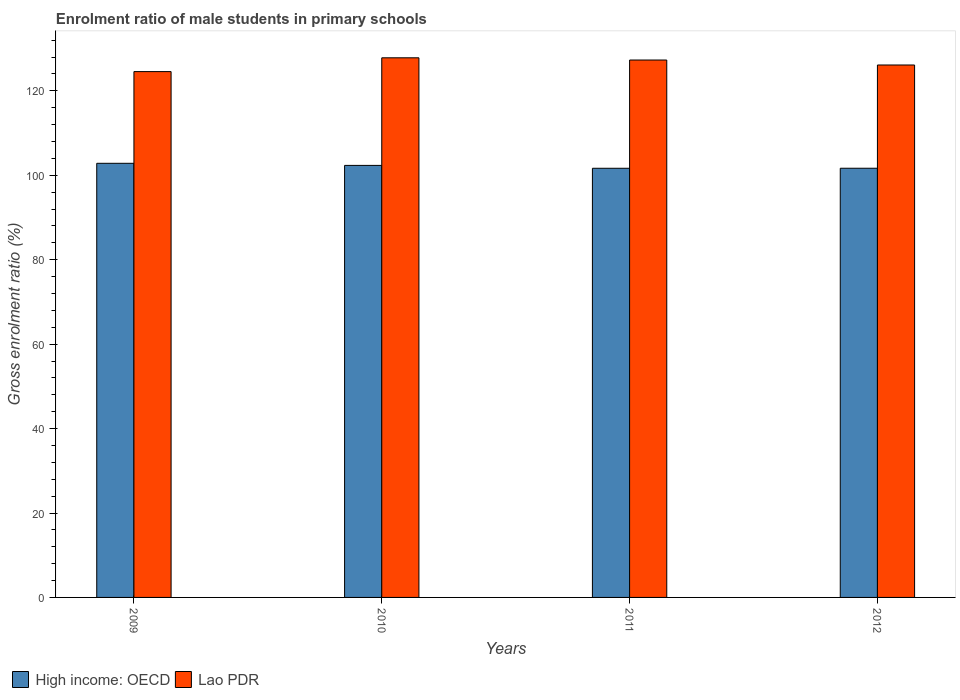Are the number of bars on each tick of the X-axis equal?
Keep it short and to the point. Yes. How many bars are there on the 3rd tick from the right?
Provide a succinct answer. 2. What is the label of the 3rd group of bars from the left?
Your response must be concise. 2011. What is the enrolment ratio of male students in primary schools in High income: OECD in 2010?
Ensure brevity in your answer.  102.35. Across all years, what is the maximum enrolment ratio of male students in primary schools in Lao PDR?
Offer a very short reply. 127.83. Across all years, what is the minimum enrolment ratio of male students in primary schools in Lao PDR?
Your response must be concise. 124.56. In which year was the enrolment ratio of male students in primary schools in High income: OECD maximum?
Provide a succinct answer. 2009. In which year was the enrolment ratio of male students in primary schools in High income: OECD minimum?
Offer a very short reply. 2011. What is the total enrolment ratio of male students in primary schools in High income: OECD in the graph?
Keep it short and to the point. 408.52. What is the difference between the enrolment ratio of male students in primary schools in Lao PDR in 2010 and that in 2012?
Your answer should be very brief. 1.7. What is the difference between the enrolment ratio of male students in primary schools in High income: OECD in 2011 and the enrolment ratio of male students in primary schools in Lao PDR in 2009?
Give a very brief answer. -22.9. What is the average enrolment ratio of male students in primary schools in High income: OECD per year?
Your answer should be compact. 102.13. In the year 2010, what is the difference between the enrolment ratio of male students in primary schools in Lao PDR and enrolment ratio of male students in primary schools in High income: OECD?
Provide a short and direct response. 25.49. In how many years, is the enrolment ratio of male students in primary schools in High income: OECD greater than 20 %?
Provide a short and direct response. 4. What is the ratio of the enrolment ratio of male students in primary schools in Lao PDR in 2010 to that in 2012?
Offer a very short reply. 1.01. Is the enrolment ratio of male students in primary schools in Lao PDR in 2009 less than that in 2010?
Provide a short and direct response. Yes. Is the difference between the enrolment ratio of male students in primary schools in Lao PDR in 2009 and 2012 greater than the difference between the enrolment ratio of male students in primary schools in High income: OECD in 2009 and 2012?
Provide a short and direct response. No. What is the difference between the highest and the second highest enrolment ratio of male students in primary schools in Lao PDR?
Make the answer very short. 0.53. What is the difference between the highest and the lowest enrolment ratio of male students in primary schools in Lao PDR?
Give a very brief answer. 3.27. In how many years, is the enrolment ratio of male students in primary schools in Lao PDR greater than the average enrolment ratio of male students in primary schools in Lao PDR taken over all years?
Your answer should be very brief. 2. What does the 2nd bar from the left in 2009 represents?
Your answer should be compact. Lao PDR. What does the 2nd bar from the right in 2010 represents?
Your response must be concise. High income: OECD. How many bars are there?
Give a very brief answer. 8. Are the values on the major ticks of Y-axis written in scientific E-notation?
Offer a very short reply. No. Does the graph contain any zero values?
Your response must be concise. No. Does the graph contain grids?
Your response must be concise. No. Where does the legend appear in the graph?
Your answer should be very brief. Bottom left. How many legend labels are there?
Provide a succinct answer. 2. How are the legend labels stacked?
Your answer should be very brief. Horizontal. What is the title of the graph?
Offer a very short reply. Enrolment ratio of male students in primary schools. What is the Gross enrolment ratio (%) of High income: OECD in 2009?
Make the answer very short. 102.84. What is the Gross enrolment ratio (%) of Lao PDR in 2009?
Provide a short and direct response. 124.56. What is the Gross enrolment ratio (%) in High income: OECD in 2010?
Your answer should be compact. 102.35. What is the Gross enrolment ratio (%) of Lao PDR in 2010?
Provide a short and direct response. 127.83. What is the Gross enrolment ratio (%) in High income: OECD in 2011?
Keep it short and to the point. 101.67. What is the Gross enrolment ratio (%) in Lao PDR in 2011?
Give a very brief answer. 127.31. What is the Gross enrolment ratio (%) in High income: OECD in 2012?
Your response must be concise. 101.67. What is the Gross enrolment ratio (%) in Lao PDR in 2012?
Provide a succinct answer. 126.13. Across all years, what is the maximum Gross enrolment ratio (%) of High income: OECD?
Offer a terse response. 102.84. Across all years, what is the maximum Gross enrolment ratio (%) of Lao PDR?
Offer a terse response. 127.83. Across all years, what is the minimum Gross enrolment ratio (%) in High income: OECD?
Your answer should be compact. 101.67. Across all years, what is the minimum Gross enrolment ratio (%) in Lao PDR?
Your response must be concise. 124.56. What is the total Gross enrolment ratio (%) in High income: OECD in the graph?
Offer a terse response. 408.52. What is the total Gross enrolment ratio (%) in Lao PDR in the graph?
Give a very brief answer. 505.84. What is the difference between the Gross enrolment ratio (%) in High income: OECD in 2009 and that in 2010?
Your response must be concise. 0.5. What is the difference between the Gross enrolment ratio (%) of Lao PDR in 2009 and that in 2010?
Provide a short and direct response. -3.27. What is the difference between the Gross enrolment ratio (%) in High income: OECD in 2009 and that in 2011?
Your response must be concise. 1.17. What is the difference between the Gross enrolment ratio (%) of Lao PDR in 2009 and that in 2011?
Ensure brevity in your answer.  -2.74. What is the difference between the Gross enrolment ratio (%) of High income: OECD in 2009 and that in 2012?
Offer a very short reply. 1.17. What is the difference between the Gross enrolment ratio (%) of Lao PDR in 2009 and that in 2012?
Your response must be concise. -1.57. What is the difference between the Gross enrolment ratio (%) in High income: OECD in 2010 and that in 2011?
Provide a succinct answer. 0.68. What is the difference between the Gross enrolment ratio (%) of Lao PDR in 2010 and that in 2011?
Give a very brief answer. 0.53. What is the difference between the Gross enrolment ratio (%) in High income: OECD in 2010 and that in 2012?
Provide a succinct answer. 0.67. What is the difference between the Gross enrolment ratio (%) in Lao PDR in 2010 and that in 2012?
Keep it short and to the point. 1.7. What is the difference between the Gross enrolment ratio (%) of High income: OECD in 2011 and that in 2012?
Your response must be concise. -0. What is the difference between the Gross enrolment ratio (%) of Lao PDR in 2011 and that in 2012?
Offer a very short reply. 1.18. What is the difference between the Gross enrolment ratio (%) in High income: OECD in 2009 and the Gross enrolment ratio (%) in Lao PDR in 2010?
Your answer should be compact. -24.99. What is the difference between the Gross enrolment ratio (%) in High income: OECD in 2009 and the Gross enrolment ratio (%) in Lao PDR in 2011?
Offer a terse response. -24.47. What is the difference between the Gross enrolment ratio (%) in High income: OECD in 2009 and the Gross enrolment ratio (%) in Lao PDR in 2012?
Make the answer very short. -23.29. What is the difference between the Gross enrolment ratio (%) of High income: OECD in 2010 and the Gross enrolment ratio (%) of Lao PDR in 2011?
Offer a very short reply. -24.96. What is the difference between the Gross enrolment ratio (%) of High income: OECD in 2010 and the Gross enrolment ratio (%) of Lao PDR in 2012?
Your answer should be compact. -23.79. What is the difference between the Gross enrolment ratio (%) in High income: OECD in 2011 and the Gross enrolment ratio (%) in Lao PDR in 2012?
Your answer should be very brief. -24.46. What is the average Gross enrolment ratio (%) of High income: OECD per year?
Your answer should be compact. 102.13. What is the average Gross enrolment ratio (%) in Lao PDR per year?
Make the answer very short. 126.46. In the year 2009, what is the difference between the Gross enrolment ratio (%) of High income: OECD and Gross enrolment ratio (%) of Lao PDR?
Keep it short and to the point. -21.72. In the year 2010, what is the difference between the Gross enrolment ratio (%) in High income: OECD and Gross enrolment ratio (%) in Lao PDR?
Your response must be concise. -25.49. In the year 2011, what is the difference between the Gross enrolment ratio (%) in High income: OECD and Gross enrolment ratio (%) in Lao PDR?
Your answer should be very brief. -25.64. In the year 2012, what is the difference between the Gross enrolment ratio (%) of High income: OECD and Gross enrolment ratio (%) of Lao PDR?
Your answer should be compact. -24.46. What is the ratio of the Gross enrolment ratio (%) of High income: OECD in 2009 to that in 2010?
Your response must be concise. 1. What is the ratio of the Gross enrolment ratio (%) of Lao PDR in 2009 to that in 2010?
Give a very brief answer. 0.97. What is the ratio of the Gross enrolment ratio (%) in High income: OECD in 2009 to that in 2011?
Provide a short and direct response. 1.01. What is the ratio of the Gross enrolment ratio (%) of Lao PDR in 2009 to that in 2011?
Provide a short and direct response. 0.98. What is the ratio of the Gross enrolment ratio (%) in High income: OECD in 2009 to that in 2012?
Your response must be concise. 1.01. What is the ratio of the Gross enrolment ratio (%) in Lao PDR in 2009 to that in 2012?
Your answer should be very brief. 0.99. What is the ratio of the Gross enrolment ratio (%) in Lao PDR in 2010 to that in 2011?
Provide a short and direct response. 1. What is the ratio of the Gross enrolment ratio (%) in High income: OECD in 2010 to that in 2012?
Make the answer very short. 1.01. What is the ratio of the Gross enrolment ratio (%) in Lao PDR in 2010 to that in 2012?
Offer a terse response. 1.01. What is the ratio of the Gross enrolment ratio (%) of Lao PDR in 2011 to that in 2012?
Offer a terse response. 1.01. What is the difference between the highest and the second highest Gross enrolment ratio (%) of High income: OECD?
Your response must be concise. 0.5. What is the difference between the highest and the second highest Gross enrolment ratio (%) of Lao PDR?
Offer a very short reply. 0.53. What is the difference between the highest and the lowest Gross enrolment ratio (%) in High income: OECD?
Ensure brevity in your answer.  1.17. What is the difference between the highest and the lowest Gross enrolment ratio (%) of Lao PDR?
Give a very brief answer. 3.27. 